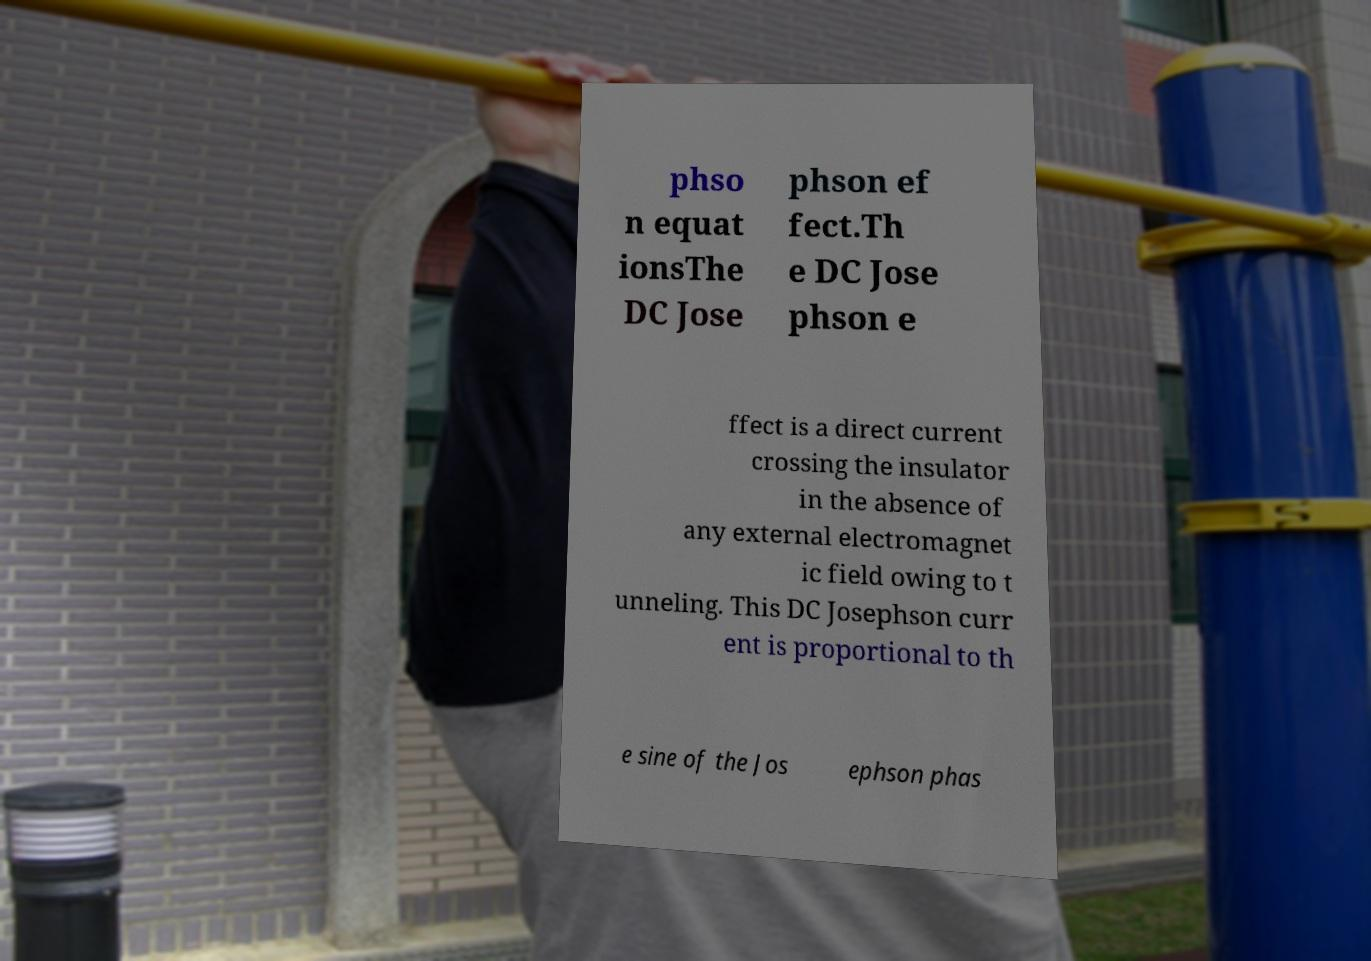Please read and relay the text visible in this image. What does it say? phso n equat ionsThe DC Jose phson ef fect.Th e DC Jose phson e ffect is a direct current crossing the insulator in the absence of any external electromagnet ic field owing to t unneling. This DC Josephson curr ent is proportional to th e sine of the Jos ephson phas 